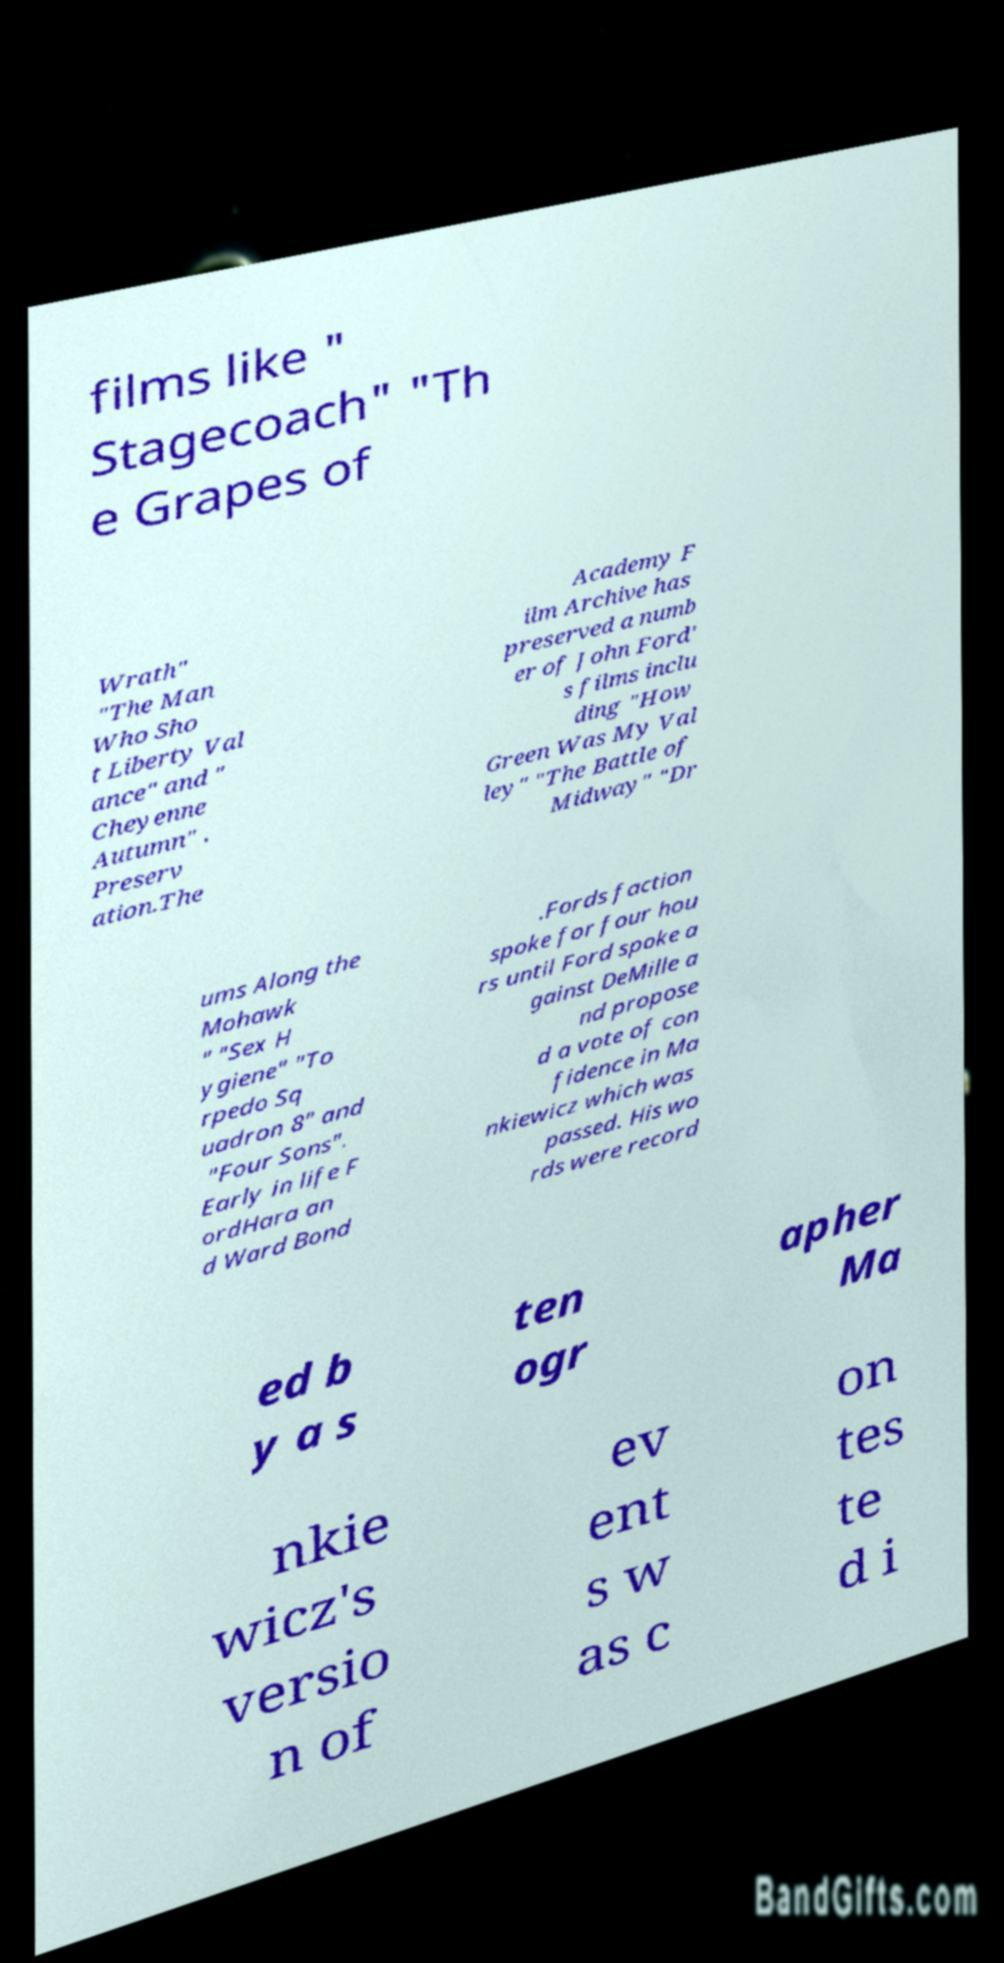There's text embedded in this image that I need extracted. Can you transcribe it verbatim? films like " Stagecoach" "Th e Grapes of Wrath" "The Man Who Sho t Liberty Val ance" and " Cheyenne Autumn" . Preserv ation.The Academy F ilm Archive has preserved a numb er of John Ford' s films inclu ding "How Green Was My Val ley" "The Battle of Midway" "Dr ums Along the Mohawk " "Sex H ygiene" "To rpedo Sq uadron 8" and "Four Sons". Early in life F ordHara an d Ward Bond .Fords faction spoke for four hou rs until Ford spoke a gainst DeMille a nd propose d a vote of con fidence in Ma nkiewicz which was passed. His wo rds were record ed b y a s ten ogr apher Ma nkie wicz's versio n of ev ent s w as c on tes te d i 